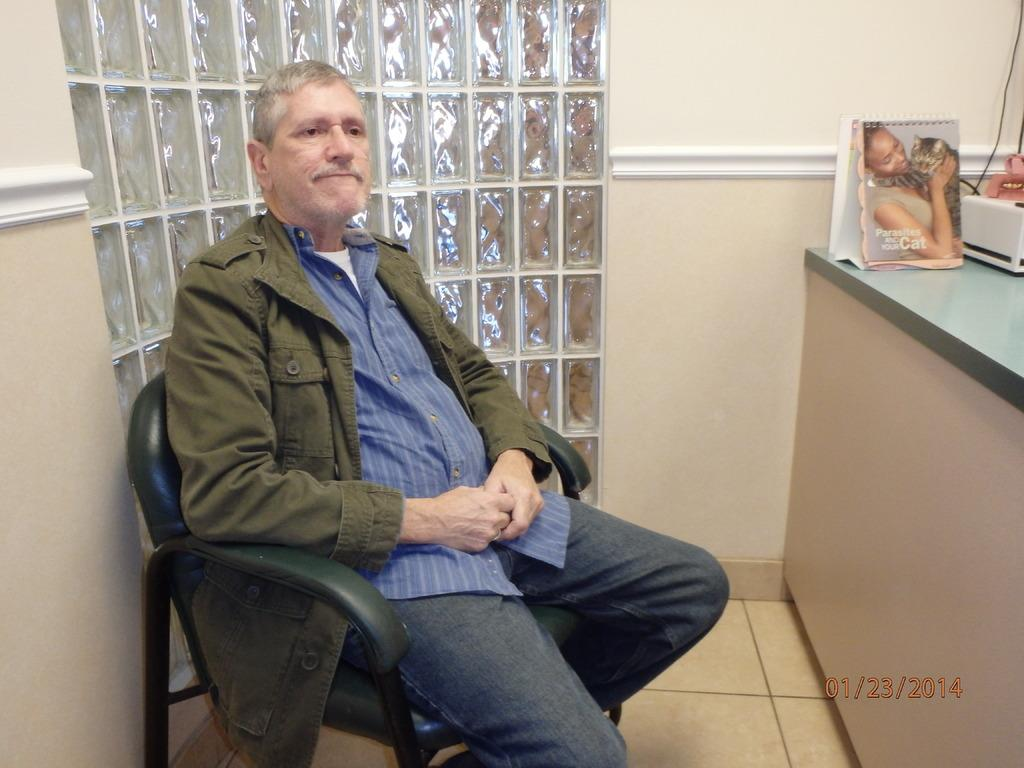What is the person in the image doing? There is a person sitting on a chair in the image. What can be seen on the right side of the image? There are objects on the right side of the image. What is the person feeling in the image? The image does not provide information about the person's emotions, so we cannot determine how they are feeling. 